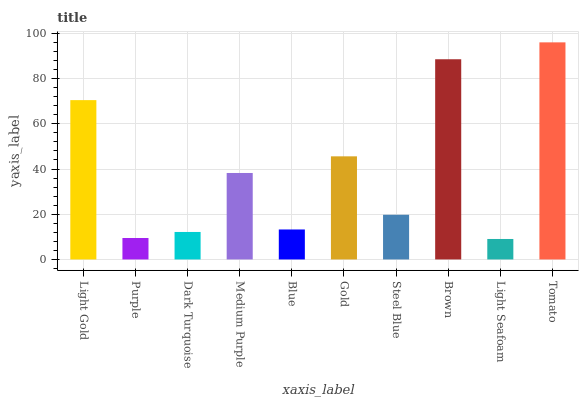Is Light Seafoam the minimum?
Answer yes or no. Yes. Is Tomato the maximum?
Answer yes or no. Yes. Is Purple the minimum?
Answer yes or no. No. Is Purple the maximum?
Answer yes or no. No. Is Light Gold greater than Purple?
Answer yes or no. Yes. Is Purple less than Light Gold?
Answer yes or no. Yes. Is Purple greater than Light Gold?
Answer yes or no. No. Is Light Gold less than Purple?
Answer yes or no. No. Is Medium Purple the high median?
Answer yes or no. Yes. Is Steel Blue the low median?
Answer yes or no. Yes. Is Brown the high median?
Answer yes or no. No. Is Blue the low median?
Answer yes or no. No. 